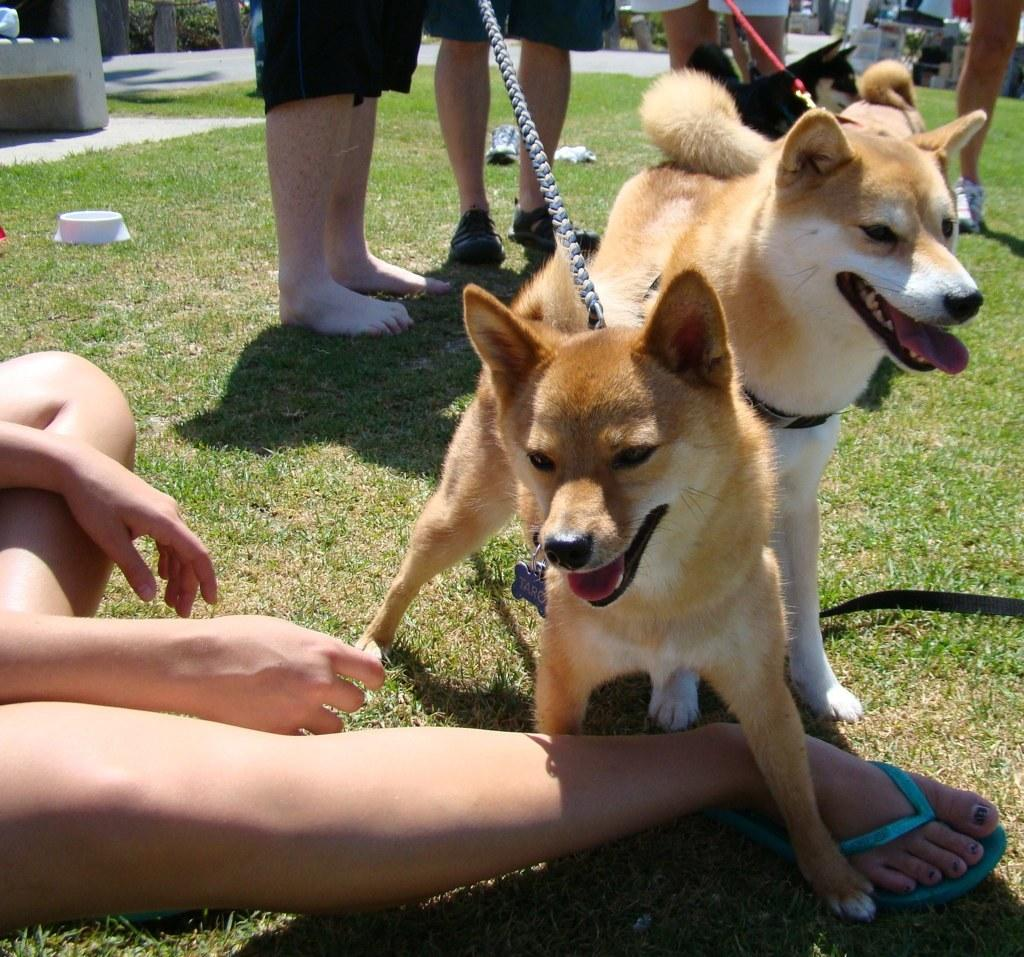What body parts are visible in the image? There are human legs visible in the image. What animals are present in the image? There are two dogs in the image. What type of terrain is visible in the image? There is grass in the image. Reasoning: Let's think step by step by step in order to produce the conversation. We start by identifying the main subjects in the image, which are the human legs and the two dogs. Then, we expand the conversation to include the terrain, which is grass. Each question is designed to elicit a specific detail about the image that is known from the provided facts. Absurd Question/Answer: What type of snails can be seen crawling on the harmony in the image? There is no harmony or snails present in the image. What type of snails can be seen crawling on the harmony in the image? There is no harmony or snails present in the image. 